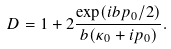Convert formula to latex. <formula><loc_0><loc_0><loc_500><loc_500>D = 1 + 2 \frac { \exp ( i b p _ { 0 } / 2 ) } { b ( \kappa _ { 0 } + i p _ { 0 } ) } .</formula> 